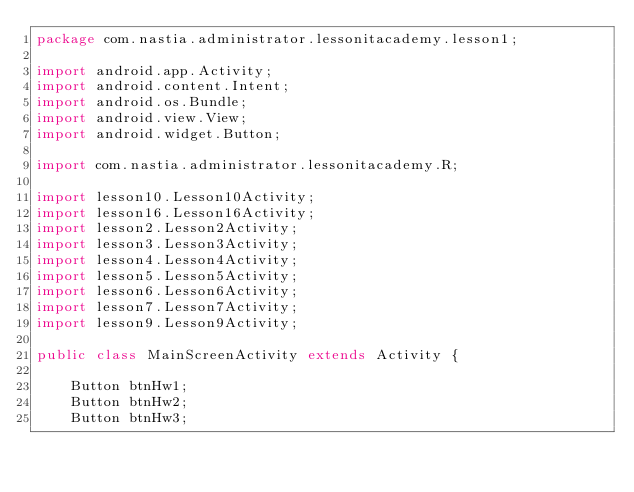Convert code to text. <code><loc_0><loc_0><loc_500><loc_500><_Java_>package com.nastia.administrator.lessonitacademy.lesson1;

import android.app.Activity;
import android.content.Intent;
import android.os.Bundle;
import android.view.View;
import android.widget.Button;

import com.nastia.administrator.lessonitacademy.R;

import lesson10.Lesson10Activity;
import lesson16.Lesson16Activity;
import lesson2.Lesson2Activity;
import lesson3.Lesson3Activity;
import lesson4.Lesson4Activity;
import lesson5.Lesson5Activity;
import lesson6.Lesson6Activity;
import lesson7.Lesson7Activity;
import lesson9.Lesson9Activity;

public class MainScreenActivity extends Activity {

    Button btnHw1;
    Button btnHw2;
    Button btnHw3;</code> 